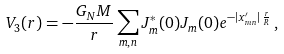Convert formula to latex. <formula><loc_0><loc_0><loc_500><loc_500>V _ { 3 } ( r ) = - \frac { G _ { N } M } { r } \sum _ { m , n } J _ { m } ^ { * } ( 0 ) J _ { m } ( 0 ) e ^ { - | x _ { m n } ^ { \prime } | \, \frac { r } { R } } \, ,</formula> 